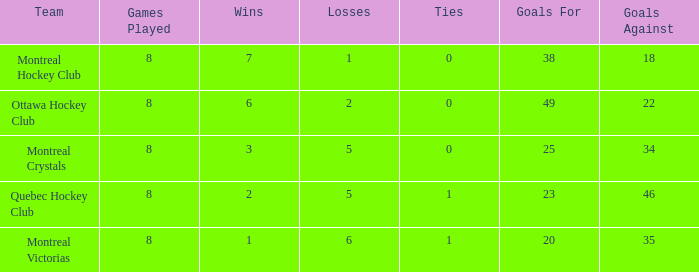What is the average losses when the wins is 3? 5.0. 